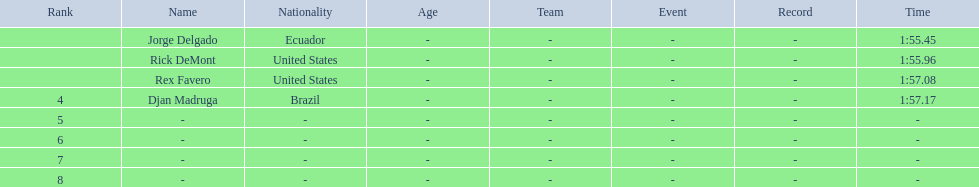Favero finished in 1:57.08. what was the next time? 1:57.17. 